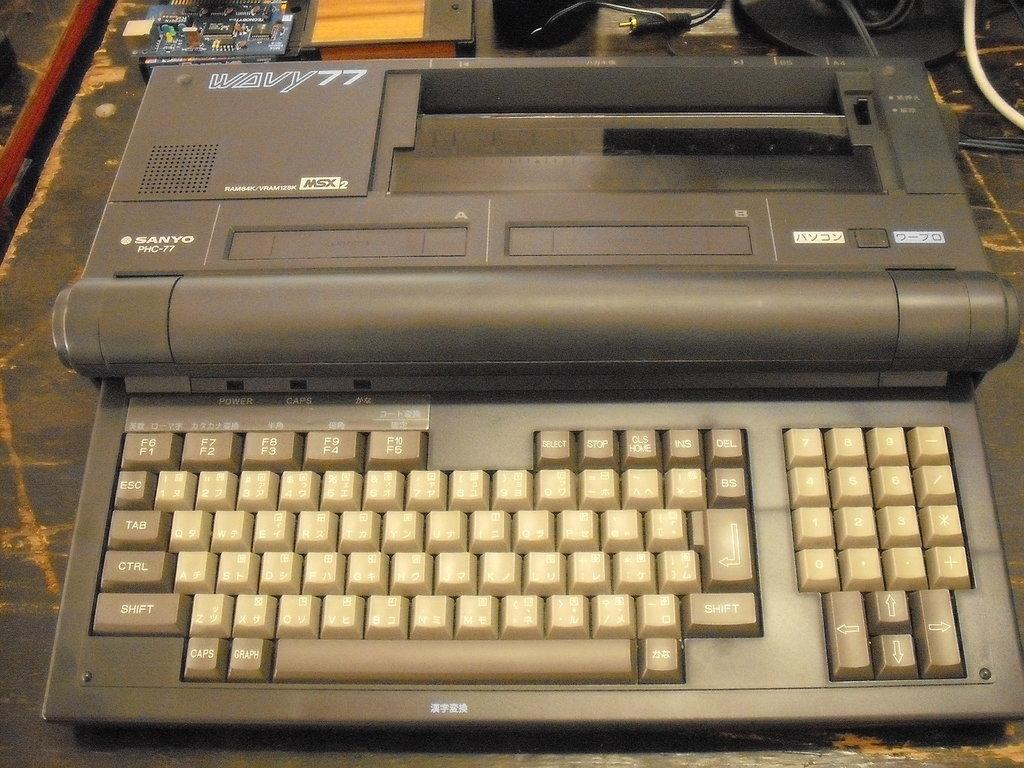<image>
Give a short and clear explanation of the subsequent image. Black keyboard with chinese letters that say "power" on the top. 